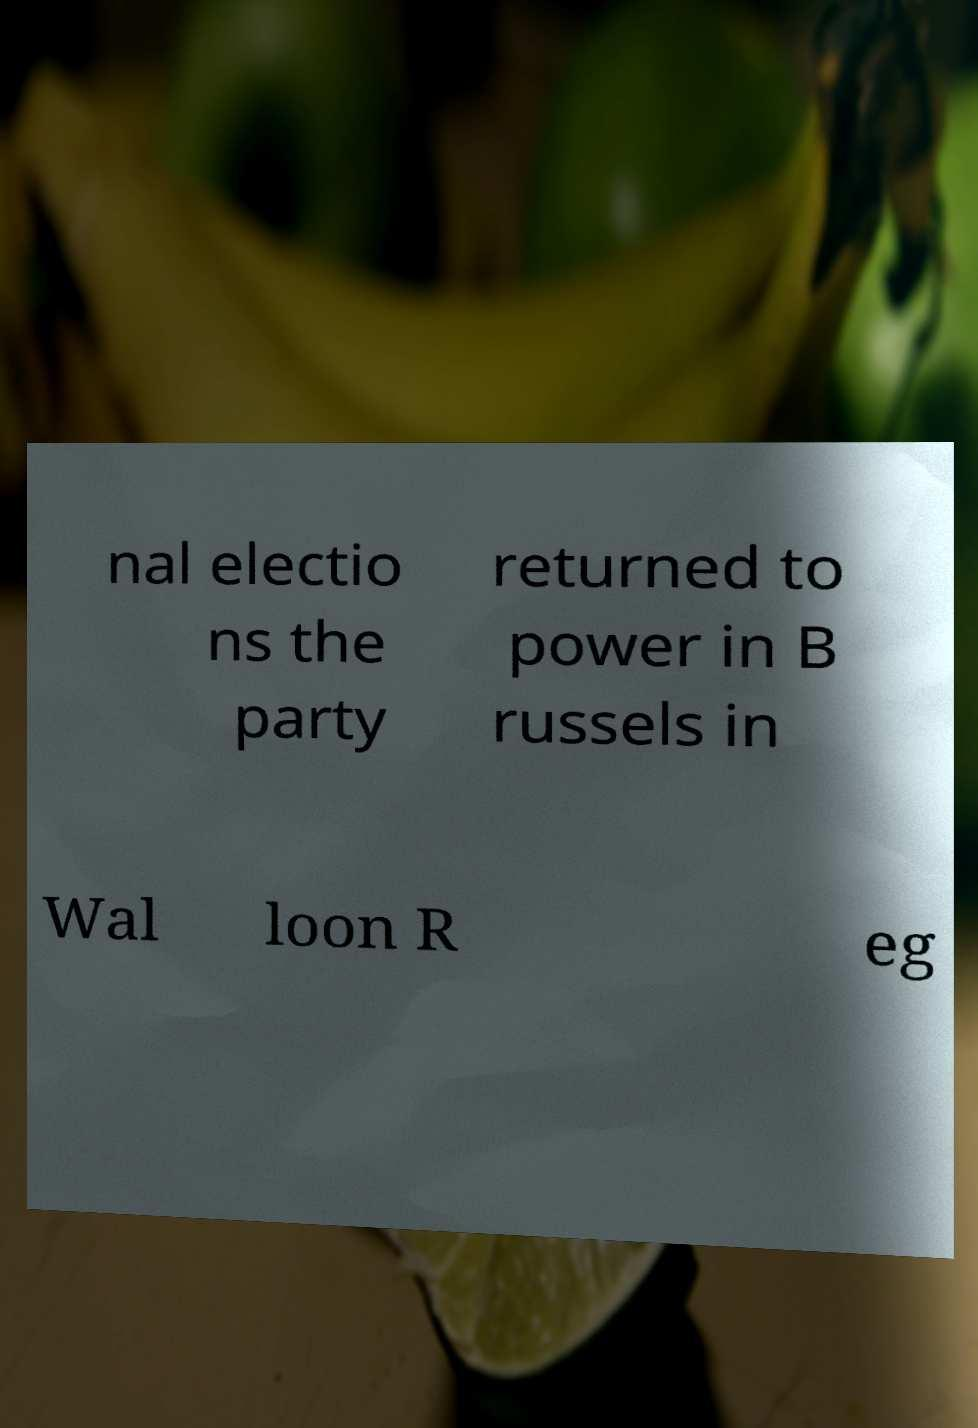What messages or text are displayed in this image? I need them in a readable, typed format. nal electio ns the party returned to power in B russels in Wal loon R eg 